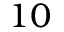<formula> <loc_0><loc_0><loc_500><loc_500>1 0</formula> 